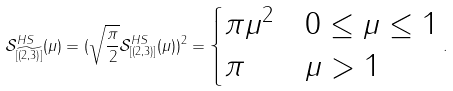Convert formula to latex. <formula><loc_0><loc_0><loc_500><loc_500>\mathcal { S } ^ { H S } _ { [ \widetilde { ( 2 , 3 ) } ] } ( \mu ) = ( \sqrt { \frac { \pi } { 2 } } \mathcal { S } ^ { H S } _ { [ ( 2 , 3 ) ] } ( \mu ) ) ^ { 2 } = \begin{cases} \pi \mu ^ { 2 } & 0 \leq \mu \leq 1 \\ \pi & \mu > 1 \end{cases} .</formula> 